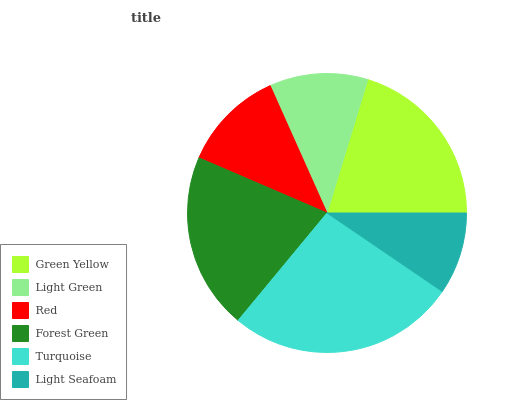Is Light Seafoam the minimum?
Answer yes or no. Yes. Is Turquoise the maximum?
Answer yes or no. Yes. Is Light Green the minimum?
Answer yes or no. No. Is Light Green the maximum?
Answer yes or no. No. Is Green Yellow greater than Light Green?
Answer yes or no. Yes. Is Light Green less than Green Yellow?
Answer yes or no. Yes. Is Light Green greater than Green Yellow?
Answer yes or no. No. Is Green Yellow less than Light Green?
Answer yes or no. No. Is Green Yellow the high median?
Answer yes or no. Yes. Is Red the low median?
Answer yes or no. Yes. Is Turquoise the high median?
Answer yes or no. No. Is Light Seafoam the low median?
Answer yes or no. No. 